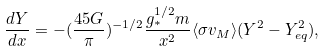<formula> <loc_0><loc_0><loc_500><loc_500>\frac { d Y } { d x } = - ( \frac { 4 5 G } { \pi } ) ^ { - 1 / 2 } \frac { g _ { * } ^ { 1 / 2 } m } { x ^ { 2 } } \langle \sigma v _ { M } \rangle ( Y ^ { 2 } - Y _ { e q } ^ { 2 } ) ,</formula> 